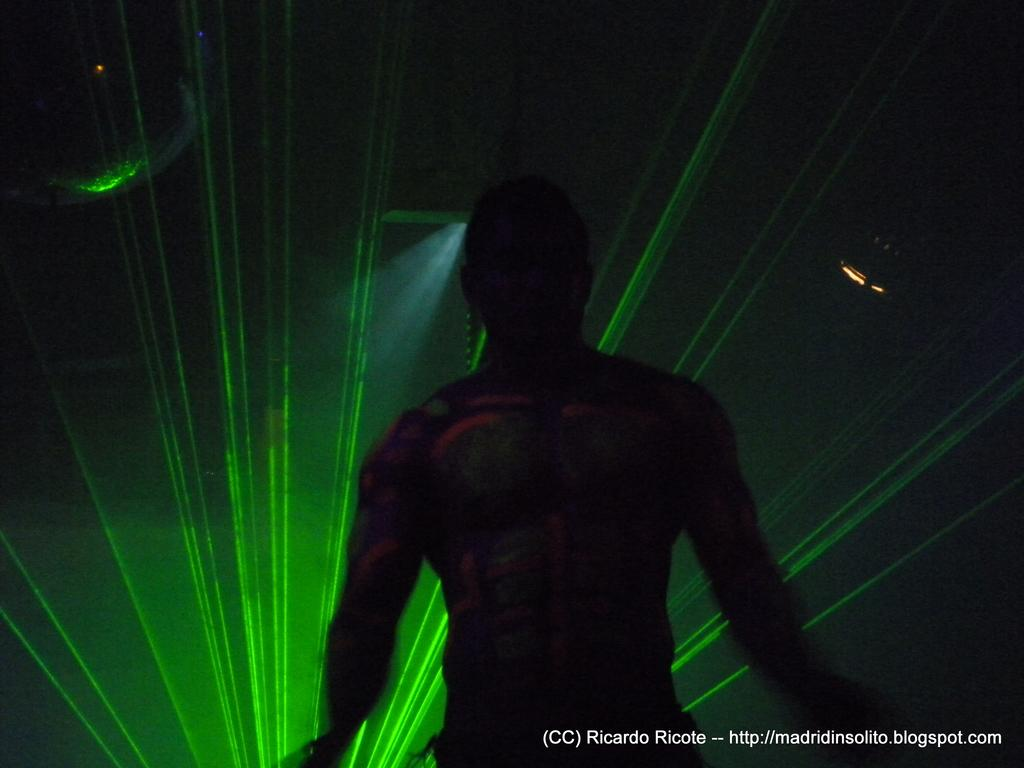What is the main subject in the foreground of the image? There is a man standing in the foreground of the image. Can you describe the environment in which the man is standing? The man is in a dark environment. What color light can be seen in the background of the image? There is a green light in the background of the image. Can you see a crown on the man's head in the image? There is no crown visible on the man's head in the image. Are there any cattle present in the image? There are no cattle present in the image. 